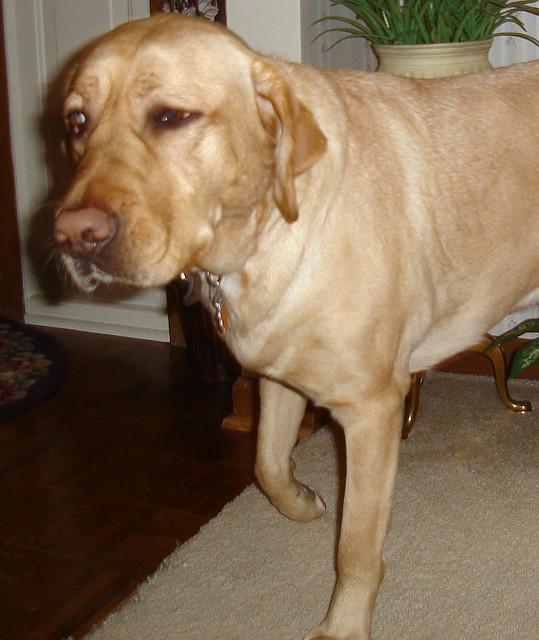How many dogs are visible?
Give a very brief answer. 1. How many people are in the image?
Give a very brief answer. 0. 